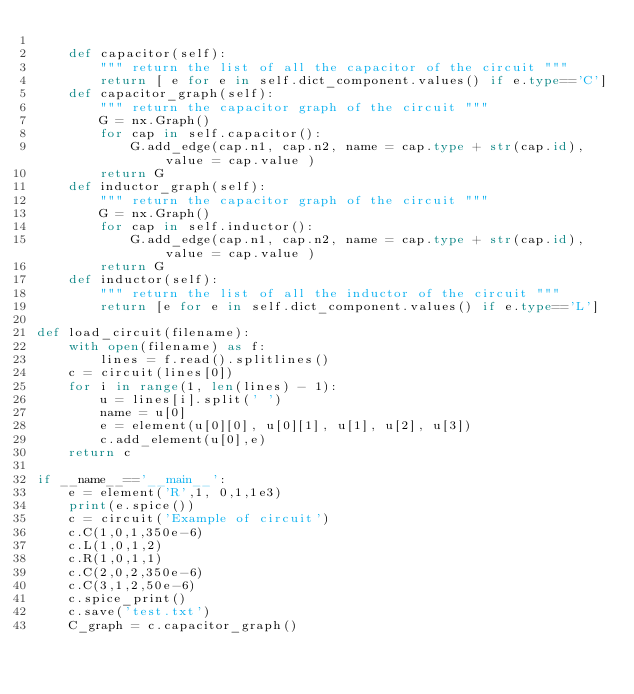Convert code to text. <code><loc_0><loc_0><loc_500><loc_500><_Python_>        
    def capacitor(self):
        """ return the list of all the capacitor of the circuit """
        return [ e for e in self.dict_component.values() if e.type=='C']
    def capacitor_graph(self):
        """ return the capacitor graph of the circuit """
        G = nx.Graph()
        for cap in self.capacitor():
            G.add_edge(cap.n1, cap.n2, name = cap.type + str(cap.id), value = cap.value )
        return G
    def inductor_graph(self):
        """ return the capacitor graph of the circuit """
        G = nx.Graph()
        for cap in self.inductor():
            G.add_edge(cap.n1, cap.n2, name = cap.type + str(cap.id), value = cap.value )
        return G
    def inductor(self):
        """ return the list of all the inductor of the circuit """
        return [e for e in self.dict_component.values() if e.type=='L']

def load_circuit(filename):
    with open(filename) as f:
        lines = f.read().splitlines()
    c = circuit(lines[0])
    for i in range(1, len(lines) - 1):
        u = lines[i].split(' ')
        name = u[0]
        e = element(u[0][0], u[0][1], u[1], u[2], u[3])
        c.add_element(u[0],e)
    return c        
    
if __name__=='__main__':
    e = element('R',1, 0,1,1e3)
    print(e.spice())
    c = circuit('Example of circuit')
    c.C(1,0,1,350e-6)
    c.L(1,0,1,2)
    c.R(1,0,1,1)
    c.C(2,0,2,350e-6)
    c.C(3,1,2,50e-6)
    c.spice_print()
    c.save('test.txt')
    C_graph = c.capacitor_graph()

</code> 